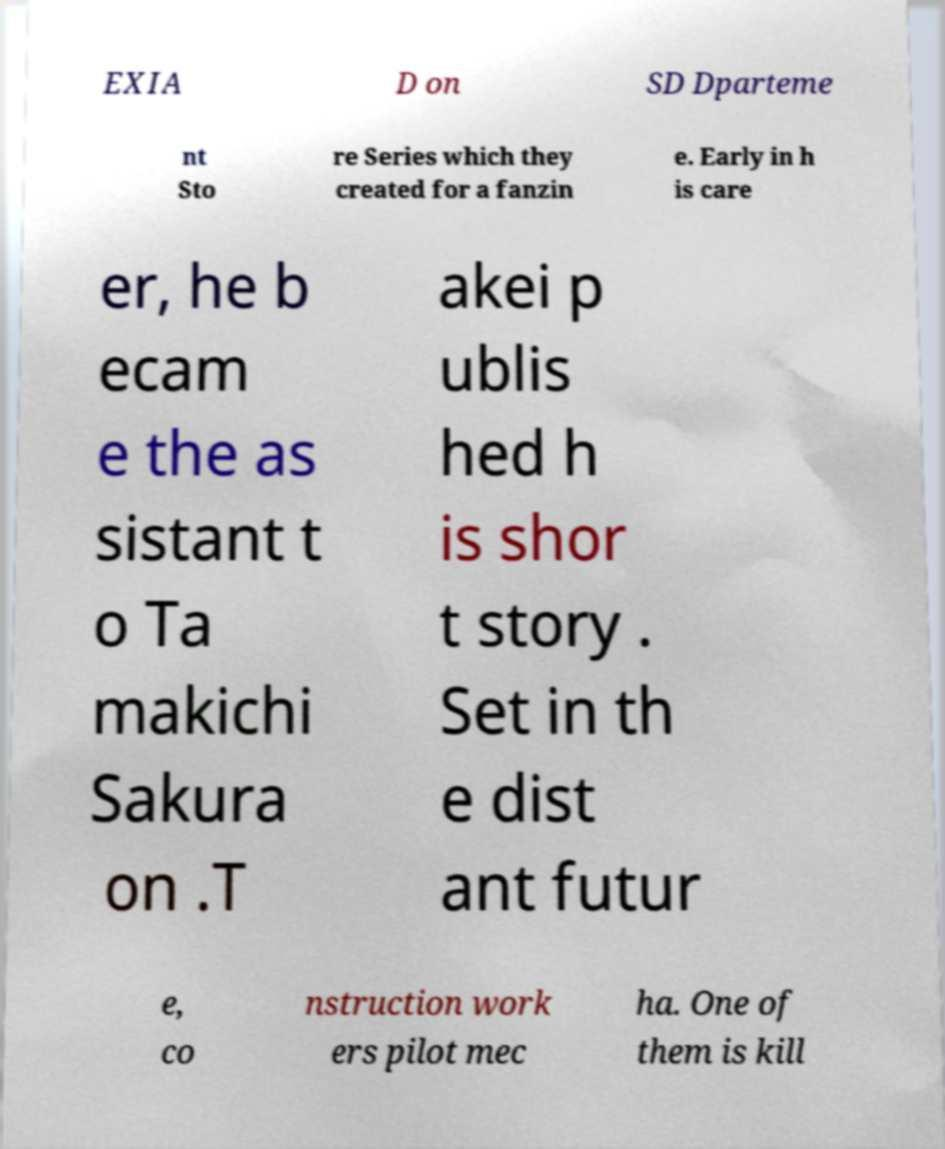Can you accurately transcribe the text from the provided image for me? EXIA D on SD Dparteme nt Sto re Series which they created for a fanzin e. Early in h is care er, he b ecam e the as sistant t o Ta makichi Sakura on .T akei p ublis hed h is shor t story . Set in th e dist ant futur e, co nstruction work ers pilot mec ha. One of them is kill 